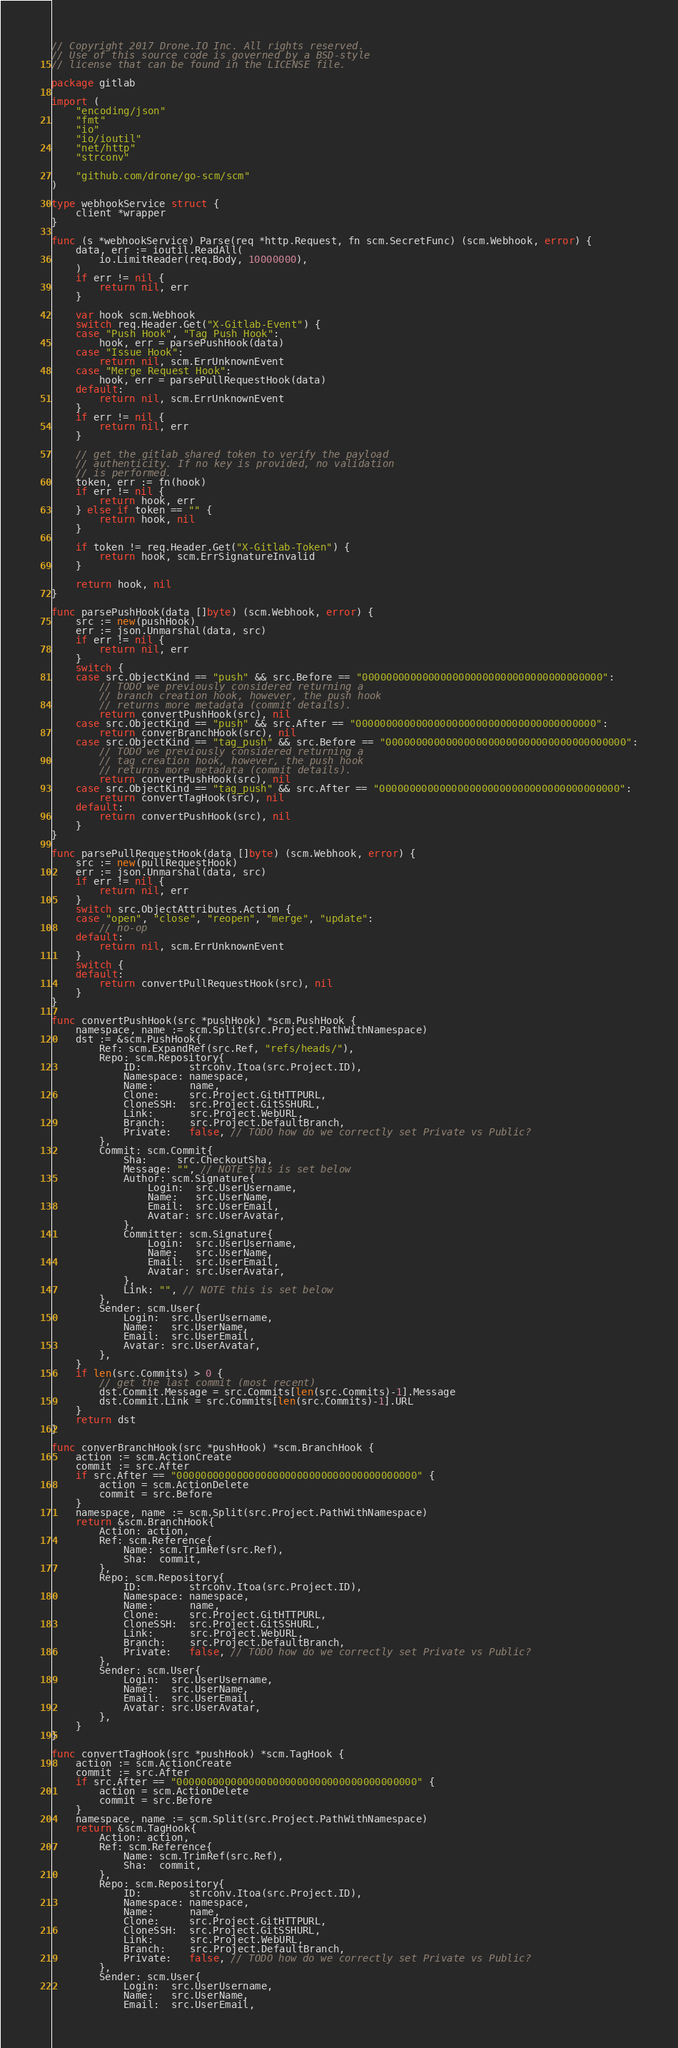<code> <loc_0><loc_0><loc_500><loc_500><_Go_>// Copyright 2017 Drone.IO Inc. All rights reserved.
// Use of this source code is governed by a BSD-style
// license that can be found in the LICENSE file.

package gitlab

import (
	"encoding/json"
	"fmt"
	"io"
	"io/ioutil"
	"net/http"
	"strconv"

	"github.com/drone/go-scm/scm"
)

type webhookService struct {
	client *wrapper
}

func (s *webhookService) Parse(req *http.Request, fn scm.SecretFunc) (scm.Webhook, error) {
	data, err := ioutil.ReadAll(
		io.LimitReader(req.Body, 10000000),
	)
	if err != nil {
		return nil, err
	}

	var hook scm.Webhook
	switch req.Header.Get("X-Gitlab-Event") {
	case "Push Hook", "Tag Push Hook":
		hook, err = parsePushHook(data)
	case "Issue Hook":
		return nil, scm.ErrUnknownEvent
	case "Merge Request Hook":
		hook, err = parsePullRequestHook(data)
	default:
		return nil, scm.ErrUnknownEvent
	}
	if err != nil {
		return nil, err
	}

	// get the gitlab shared token to verify the payload
	// authenticity. If no key is provided, no validation
	// is performed.
	token, err := fn(hook)
	if err != nil {
		return hook, err
	} else if token == "" {
		return hook, nil
	}

	if token != req.Header.Get("X-Gitlab-Token") {
		return hook, scm.ErrSignatureInvalid
	}

	return hook, nil
}

func parsePushHook(data []byte) (scm.Webhook, error) {
	src := new(pushHook)
	err := json.Unmarshal(data, src)
	if err != nil {
		return nil, err
	}
	switch {
	case src.ObjectKind == "push" && src.Before == "0000000000000000000000000000000000000000":
		// TODO we previously considered returning a
		// branch creation hook, however, the push hook
		// returns more metadata (commit details).
		return convertPushHook(src), nil
	case src.ObjectKind == "push" && src.After == "0000000000000000000000000000000000000000":
		return converBranchHook(src), nil
	case src.ObjectKind == "tag_push" && src.Before == "0000000000000000000000000000000000000000":
		// TODO we previously considered returning a
		// tag creation hook, however, the push hook
		// returns more metadata (commit details).
		return convertPushHook(src), nil
	case src.ObjectKind == "tag_push" && src.After == "0000000000000000000000000000000000000000":
		return convertTagHook(src), nil
	default:
		return convertPushHook(src), nil
	}
}

func parsePullRequestHook(data []byte) (scm.Webhook, error) {
	src := new(pullRequestHook)
	err := json.Unmarshal(data, src)
	if err != nil {
		return nil, err
	}
	switch src.ObjectAttributes.Action {
	case "open", "close", "reopen", "merge", "update":
		// no-op
	default:
		return nil, scm.ErrUnknownEvent
	}
	switch {
	default:
		return convertPullRequestHook(src), nil
	}
}

func convertPushHook(src *pushHook) *scm.PushHook {
	namespace, name := scm.Split(src.Project.PathWithNamespace)
	dst := &scm.PushHook{
		Ref: scm.ExpandRef(src.Ref, "refs/heads/"),
		Repo: scm.Repository{
			ID:        strconv.Itoa(src.Project.ID),
			Namespace: namespace,
			Name:      name,
			Clone:     src.Project.GitHTTPURL,
			CloneSSH:  src.Project.GitSSHURL,
			Link:      src.Project.WebURL,
			Branch:    src.Project.DefaultBranch,
			Private:   false, // TODO how do we correctly set Private vs Public?
		},
		Commit: scm.Commit{
			Sha:     src.CheckoutSha,
			Message: "", // NOTE this is set below
			Author: scm.Signature{
				Login:  src.UserUsername,
				Name:   src.UserName,
				Email:  src.UserEmail,
				Avatar: src.UserAvatar,
			},
			Committer: scm.Signature{
				Login:  src.UserUsername,
				Name:   src.UserName,
				Email:  src.UserEmail,
				Avatar: src.UserAvatar,
			},
			Link: "", // NOTE this is set below
		},
		Sender: scm.User{
			Login:  src.UserUsername,
			Name:   src.UserName,
			Email:  src.UserEmail,
			Avatar: src.UserAvatar,
		},
	}
	if len(src.Commits) > 0 {
		// get the last commit (most recent)
		dst.Commit.Message = src.Commits[len(src.Commits)-1].Message
		dst.Commit.Link = src.Commits[len(src.Commits)-1].URL
	}
	return dst
}

func converBranchHook(src *pushHook) *scm.BranchHook {
	action := scm.ActionCreate
	commit := src.After
	if src.After == "0000000000000000000000000000000000000000" {
		action = scm.ActionDelete
		commit = src.Before
	}
	namespace, name := scm.Split(src.Project.PathWithNamespace)
	return &scm.BranchHook{
		Action: action,
		Ref: scm.Reference{
			Name: scm.TrimRef(src.Ref),
			Sha:  commit,
		},
		Repo: scm.Repository{
			ID:        strconv.Itoa(src.Project.ID),
			Namespace: namespace,
			Name:      name,
			Clone:     src.Project.GitHTTPURL,
			CloneSSH:  src.Project.GitSSHURL,
			Link:      src.Project.WebURL,
			Branch:    src.Project.DefaultBranch,
			Private:   false, // TODO how do we correctly set Private vs Public?
		},
		Sender: scm.User{
			Login:  src.UserUsername,
			Name:   src.UserName,
			Email:  src.UserEmail,
			Avatar: src.UserAvatar,
		},
	}
}

func convertTagHook(src *pushHook) *scm.TagHook {
	action := scm.ActionCreate
	commit := src.After
	if src.After == "0000000000000000000000000000000000000000" {
		action = scm.ActionDelete
		commit = src.Before
	}
	namespace, name := scm.Split(src.Project.PathWithNamespace)
	return &scm.TagHook{
		Action: action,
		Ref: scm.Reference{
			Name: scm.TrimRef(src.Ref),
			Sha:  commit,
		},
		Repo: scm.Repository{
			ID:        strconv.Itoa(src.Project.ID),
			Namespace: namespace,
			Name:      name,
			Clone:     src.Project.GitHTTPURL,
			CloneSSH:  src.Project.GitSSHURL,
			Link:      src.Project.WebURL,
			Branch:    src.Project.DefaultBranch,
			Private:   false, // TODO how do we correctly set Private vs Public?
		},
		Sender: scm.User{
			Login:  src.UserUsername,
			Name:   src.UserName,
			Email:  src.UserEmail,</code> 